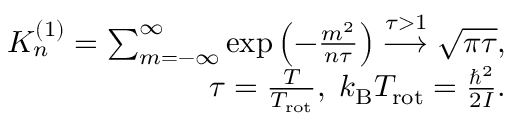<formula> <loc_0><loc_0><loc_500><loc_500>\begin{array} { r } { K _ { n } ^ { ( 1 ) } = \sum _ { m = - \infty } ^ { \infty } \exp \left ( - \frac { m ^ { 2 } } { n \tau } \right ) \overset { \tau > 1 } { \longrightarrow } \sqrt { \pi \tau } , } \\ { \tau = \frac { T } { T _ { r o t } } , \, k _ { B } T _ { r o t } = \frac { \hbar { ^ } { 2 } } { 2 I } . } \end{array}</formula> 